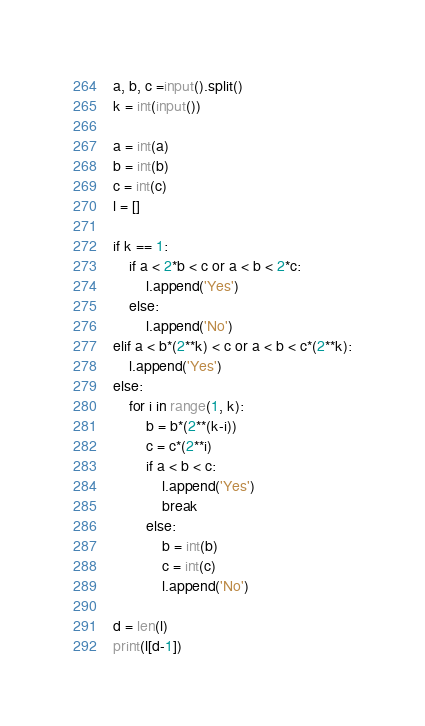<code> <loc_0><loc_0><loc_500><loc_500><_Python_>a, b, c =input().split()
k = int(input())

a = int(a)
b = int(b)
c = int(c)
l = []

if k == 1:
    if a < 2*b < c or a < b < 2*c:
        l.append('Yes')
    else:
        l.append('No')
elif a < b*(2**k) < c or a < b < c*(2**k):
    l.append('Yes')
else:
    for i in range(1, k):
        b = b*(2**(k-i))
        c = c*(2**i)
        if a < b < c:
            l.append('Yes')
            break
        else:
            b = int(b)
            c = int(c)
            l.append('No')

d = len(l)
print(l[d-1])</code> 